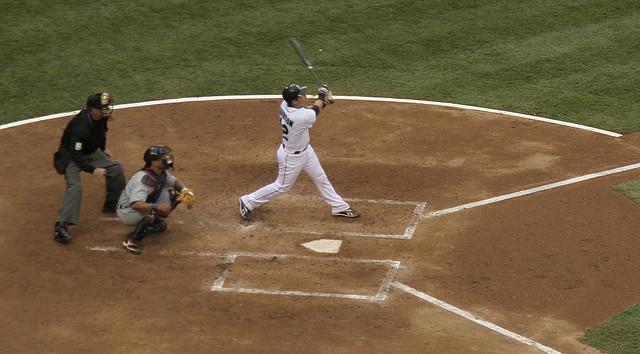Is the baseball player taking a swing?
Give a very brief answer. Yes. Who is wearing a mask?
Short answer required. Catcher. Is this hitter hitting left- or right-handed?
Quick response, please. Right. What color is the umpire's shirt?
Answer briefly. Black. Is the swing taken by the baseball player?
Concise answer only. Yes. Was it a strike or ball?
Answer briefly. Strike. Is everyone the same gender?
Short answer required. Yes. What color is the batter's helmet?
Give a very brief answer. Black. 